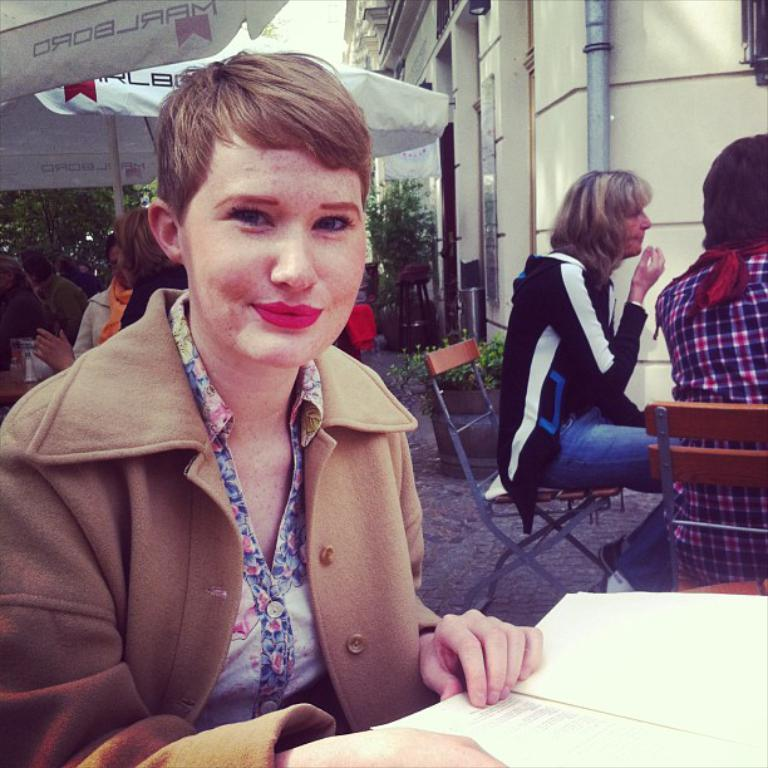What are the people in the image doing? The people in the image are sitting on chairs. Can you describe what one of the people is holding? One of the people is holding a book. What can be seen in the background of the image? In the background of the image, there are umbrellas, buildings, plants, and poles. What type of stem can be seen growing from the ship in the image? There is no ship present in the image, and therefore no stem can be observed. What color are the teeth of the person holding the book in the image? There is no indication of the person's teeth in the image, as the focus is on the book they are holding. 